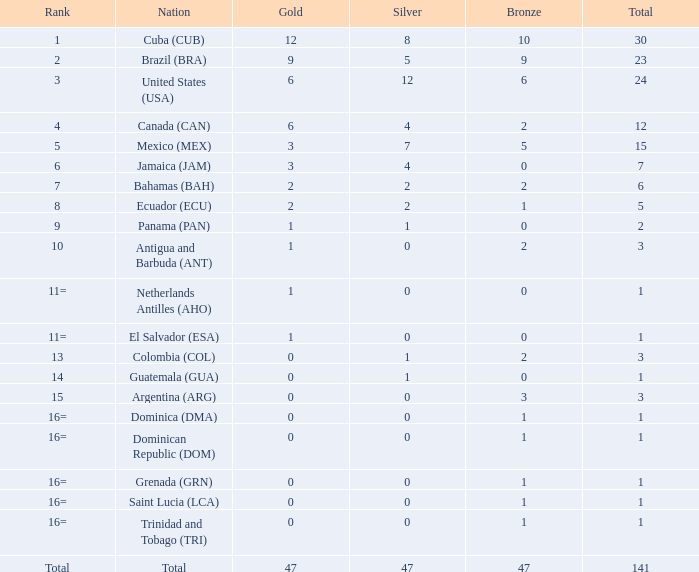Write the full table. {'header': ['Rank', 'Nation', 'Gold', 'Silver', 'Bronze', 'Total'], 'rows': [['1', 'Cuba (CUB)', '12', '8', '10', '30'], ['2', 'Brazil (BRA)', '9', '5', '9', '23'], ['3', 'United States (USA)', '6', '12', '6', '24'], ['4', 'Canada (CAN)', '6', '4', '2', '12'], ['5', 'Mexico (MEX)', '3', '7', '5', '15'], ['6', 'Jamaica (JAM)', '3', '4', '0', '7'], ['7', 'Bahamas (BAH)', '2', '2', '2', '6'], ['8', 'Ecuador (ECU)', '2', '2', '1', '5'], ['9', 'Panama (PAN)', '1', '1', '0', '2'], ['10', 'Antigua and Barbuda (ANT)', '1', '0', '2', '3'], ['11=', 'Netherlands Antilles (AHO)', '1', '0', '0', '1'], ['11=', 'El Salvador (ESA)', '1', '0', '0', '1'], ['13', 'Colombia (COL)', '0', '1', '2', '3'], ['14', 'Guatemala (GUA)', '0', '1', '0', '1'], ['15', 'Argentina (ARG)', '0', '0', '3', '3'], ['16=', 'Dominica (DMA)', '0', '0', '1', '1'], ['16=', 'Dominican Republic (DOM)', '0', '0', '1', '1'], ['16=', 'Grenada (GRN)', '0', '0', '1', '1'], ['16=', 'Saint Lucia (LCA)', '0', '0', '1', '1'], ['16=', 'Trinidad and Tobago (TRI)', '0', '0', '1', '1'], ['Total', 'Total', '47', '47', '47', '141']]} What is the overall gold amount when the sum is below 1? None. 